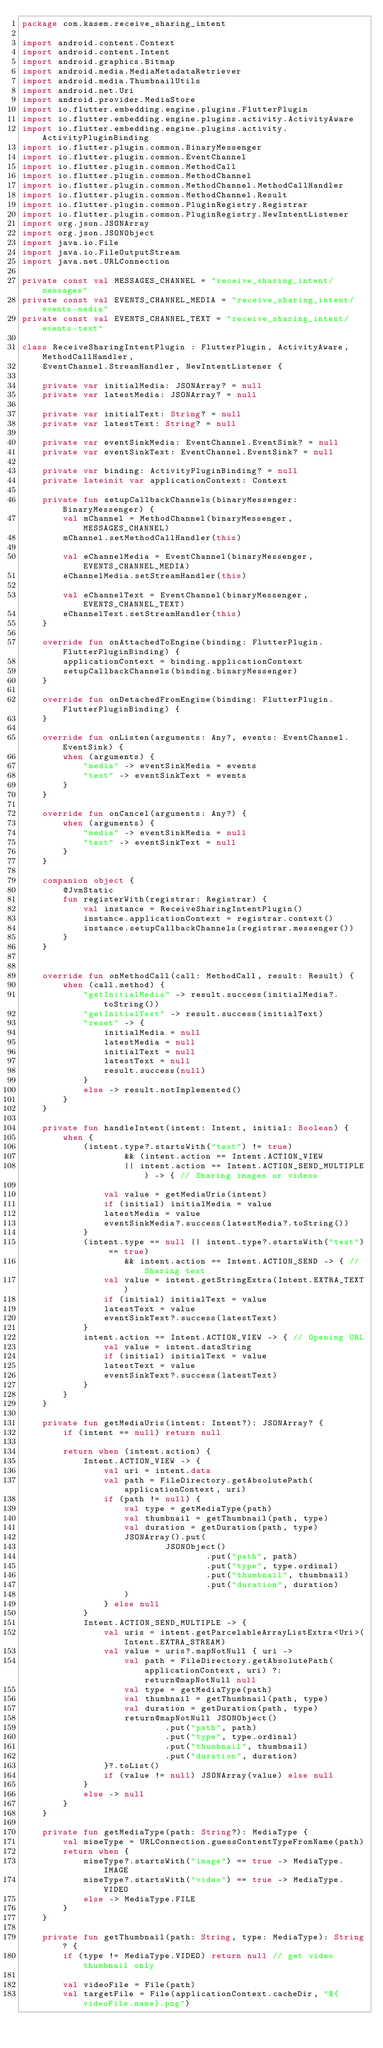<code> <loc_0><loc_0><loc_500><loc_500><_Kotlin_>package com.kasem.receive_sharing_intent

import android.content.Context
import android.content.Intent
import android.graphics.Bitmap
import android.media.MediaMetadataRetriever
import android.media.ThumbnailUtils
import android.net.Uri
import android.provider.MediaStore
import io.flutter.embedding.engine.plugins.FlutterPlugin
import io.flutter.embedding.engine.plugins.activity.ActivityAware
import io.flutter.embedding.engine.plugins.activity.ActivityPluginBinding
import io.flutter.plugin.common.BinaryMessenger
import io.flutter.plugin.common.EventChannel
import io.flutter.plugin.common.MethodCall
import io.flutter.plugin.common.MethodChannel
import io.flutter.plugin.common.MethodChannel.MethodCallHandler
import io.flutter.plugin.common.MethodChannel.Result
import io.flutter.plugin.common.PluginRegistry.Registrar
import io.flutter.plugin.common.PluginRegistry.NewIntentListener
import org.json.JSONArray
import org.json.JSONObject
import java.io.File
import java.io.FileOutputStream
import java.net.URLConnection

private const val MESSAGES_CHANNEL = "receive_sharing_intent/messages"
private const val EVENTS_CHANNEL_MEDIA = "receive_sharing_intent/events-media"
private const val EVENTS_CHANNEL_TEXT = "receive_sharing_intent/events-text"

class ReceiveSharingIntentPlugin : FlutterPlugin, ActivityAware, MethodCallHandler,
    EventChannel.StreamHandler, NewIntentListener {

    private var initialMedia: JSONArray? = null
    private var latestMedia: JSONArray? = null

    private var initialText: String? = null
    private var latestText: String? = null

    private var eventSinkMedia: EventChannel.EventSink? = null
    private var eventSinkText: EventChannel.EventSink? = null

    private var binding: ActivityPluginBinding? = null
    private lateinit var applicationContext: Context

    private fun setupCallbackChannels(binaryMessenger: BinaryMessenger) {
        val mChannel = MethodChannel(binaryMessenger, MESSAGES_CHANNEL)
        mChannel.setMethodCallHandler(this)

        val eChannelMedia = EventChannel(binaryMessenger, EVENTS_CHANNEL_MEDIA)
        eChannelMedia.setStreamHandler(this)

        val eChannelText = EventChannel(binaryMessenger, EVENTS_CHANNEL_TEXT)
        eChannelText.setStreamHandler(this)
    }

    override fun onAttachedToEngine(binding: FlutterPlugin.FlutterPluginBinding) {
        applicationContext = binding.applicationContext
        setupCallbackChannels(binding.binaryMessenger)
    }

    override fun onDetachedFromEngine(binding: FlutterPlugin.FlutterPluginBinding) {
    }

    override fun onListen(arguments: Any?, events: EventChannel.EventSink) {
        when (arguments) {
            "media" -> eventSinkMedia = events
            "text" -> eventSinkText = events
        }
    }

    override fun onCancel(arguments: Any?) {
        when (arguments) {
            "media" -> eventSinkMedia = null
            "text" -> eventSinkText = null
        }
    }

    companion object {
        @JvmStatic
        fun registerWith(registrar: Registrar) {
            val instance = ReceiveSharingIntentPlugin()
            instance.applicationContext = registrar.context()
            instance.setupCallbackChannels(registrar.messenger())
        }
    }


    override fun onMethodCall(call: MethodCall, result: Result) {
        when (call.method) {
            "getInitialMedia" -> result.success(initialMedia?.toString())
            "getInitialText" -> result.success(initialText)
            "reset" -> {
                initialMedia = null
                latestMedia = null
                initialText = null
                latestText = null
                result.success(null)
            }
            else -> result.notImplemented()
        }
    }

    private fun handleIntent(intent: Intent, initial: Boolean) {
        when {
            (intent.type?.startsWith("text") != true)
                    && (intent.action == Intent.ACTION_VIEW
                    || intent.action == Intent.ACTION_SEND_MULTIPLE) -> { // Sharing images or videos

                val value = getMediaUris(intent)
                if (initial) initialMedia = value
                latestMedia = value
                eventSinkMedia?.success(latestMedia?.toString())
            }
            (intent.type == null || intent.type?.startsWith("text") == true)
                    && intent.action == Intent.ACTION_SEND -> { // Sharing text
                val value = intent.getStringExtra(Intent.EXTRA_TEXT)
                if (initial) initialText = value
                latestText = value
                eventSinkText?.success(latestText)
            }
            intent.action == Intent.ACTION_VIEW -> { // Opening URL
                val value = intent.dataString
                if (initial) initialText = value
                latestText = value
                eventSinkText?.success(latestText)
            }
        }
    }

    private fun getMediaUris(intent: Intent?): JSONArray? {
        if (intent == null) return null

        return when (intent.action) {
            Intent.ACTION_VIEW -> {
                val uri = intent.data
                val path = FileDirectory.getAbsolutePath(applicationContext, uri)
                if (path != null) {
                    val type = getMediaType(path)
                    val thumbnail = getThumbnail(path, type)
                    val duration = getDuration(path, type)
                    JSONArray().put(
                            JSONObject()
                                    .put("path", path)
                                    .put("type", type.ordinal)
                                    .put("thumbnail", thumbnail)
                                    .put("duration", duration)
                    )
                } else null
            }
            Intent.ACTION_SEND_MULTIPLE -> {
                val uris = intent.getParcelableArrayListExtra<Uri>(Intent.EXTRA_STREAM)
                val value = uris?.mapNotNull { uri ->
                    val path = FileDirectory.getAbsolutePath(applicationContext, uri) ?: return@mapNotNull null
                    val type = getMediaType(path)
                    val thumbnail = getThumbnail(path, type)
                    val duration = getDuration(path, type)
                    return@mapNotNull JSONObject()
                            .put("path", path)
                            .put("type", type.ordinal)
                            .put("thumbnail", thumbnail)
                            .put("duration", duration)
                }?.toList()
                if (value != null) JSONArray(value) else null
            }
            else -> null
        }
    }

    private fun getMediaType(path: String?): MediaType {
        val mimeType = URLConnection.guessContentTypeFromName(path)
        return when {
            mimeType?.startsWith("image") == true -> MediaType.IMAGE
            mimeType?.startsWith("video") == true -> MediaType.VIDEO
            else -> MediaType.FILE
        }
    }

    private fun getThumbnail(path: String, type: MediaType): String? {
        if (type != MediaType.VIDEO) return null // get video thumbnail only

        val videoFile = File(path)
        val targetFile = File(applicationContext.cacheDir, "${videoFile.name}.png")</code> 